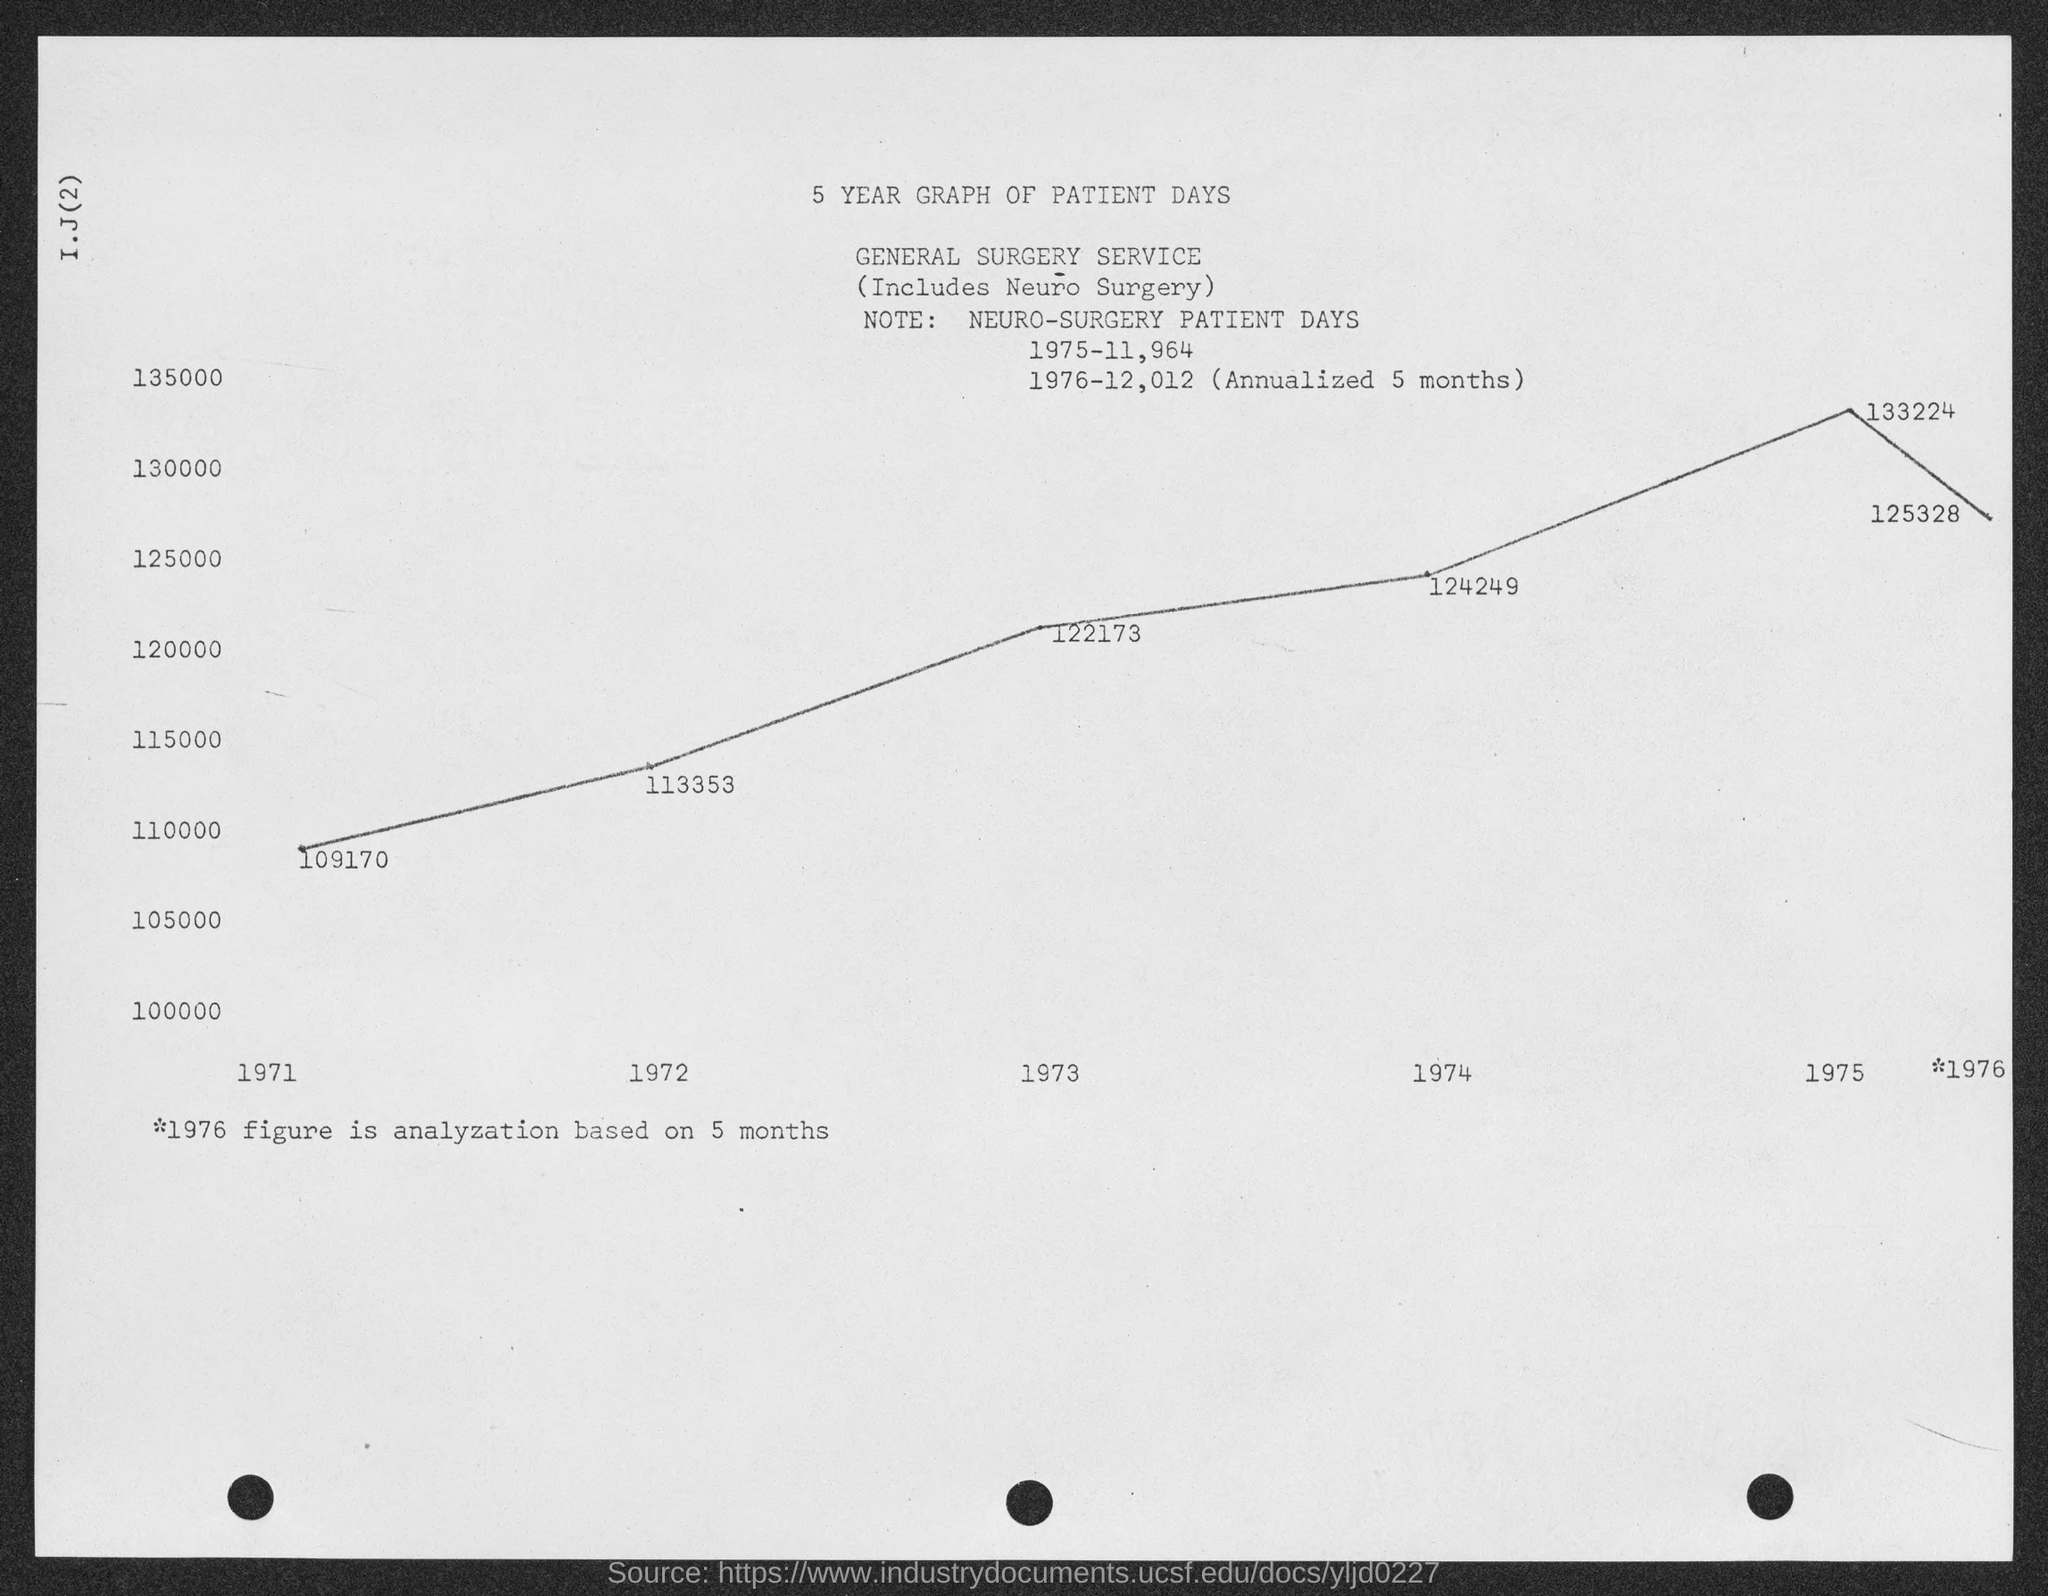What is the first title in the document?
Offer a very short reply. 5 YEAR GRAPH OF PATIENT DAYS. What is the second title in the document?
Offer a terse response. General surgery service. What is the lowest value plotted on the graph?
Provide a succinct answer. 109170. What is the highest value plotted on the graph?
Make the answer very short. 133224. 